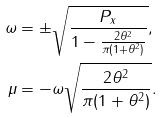Convert formula to latex. <formula><loc_0><loc_0><loc_500><loc_500>\omega & = \pm \sqrt { \frac { P _ { x } } { 1 - \frac { 2 \theta ^ { 2 } } { \pi ( 1 + \theta ^ { 2 } ) } } } , \\ \mu & = - \omega \sqrt { \frac { 2 \theta ^ { 2 } } { \pi ( 1 + \theta ^ { 2 } ) } } .</formula> 